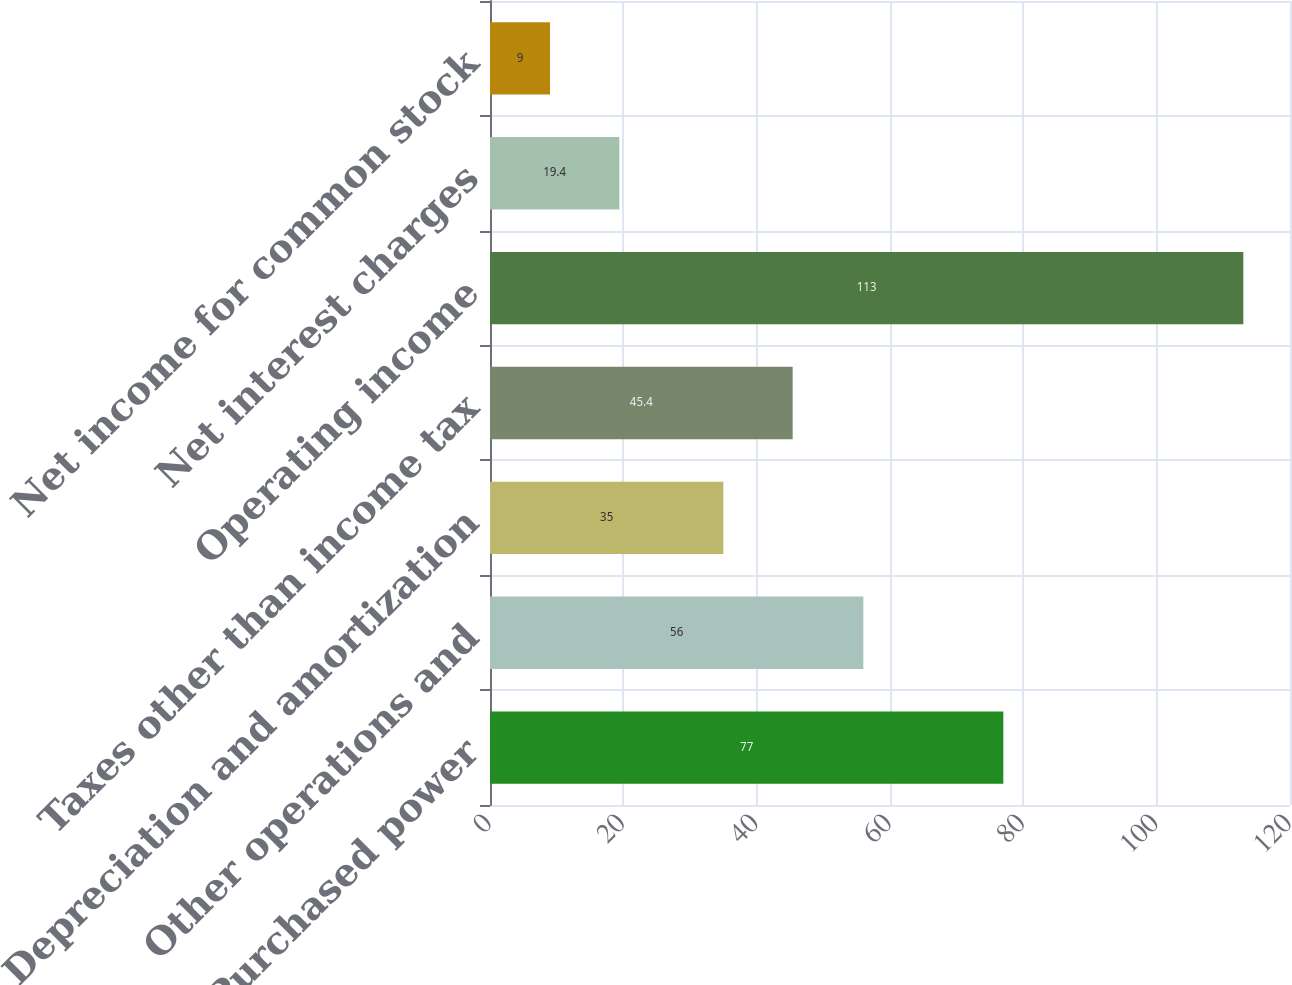<chart> <loc_0><loc_0><loc_500><loc_500><bar_chart><fcel>Purchased power<fcel>Other operations and<fcel>Depreciation and amortization<fcel>Taxes other than income tax<fcel>Operating income<fcel>Net interest charges<fcel>Net income for common stock<nl><fcel>77<fcel>56<fcel>35<fcel>45.4<fcel>113<fcel>19.4<fcel>9<nl></chart> 